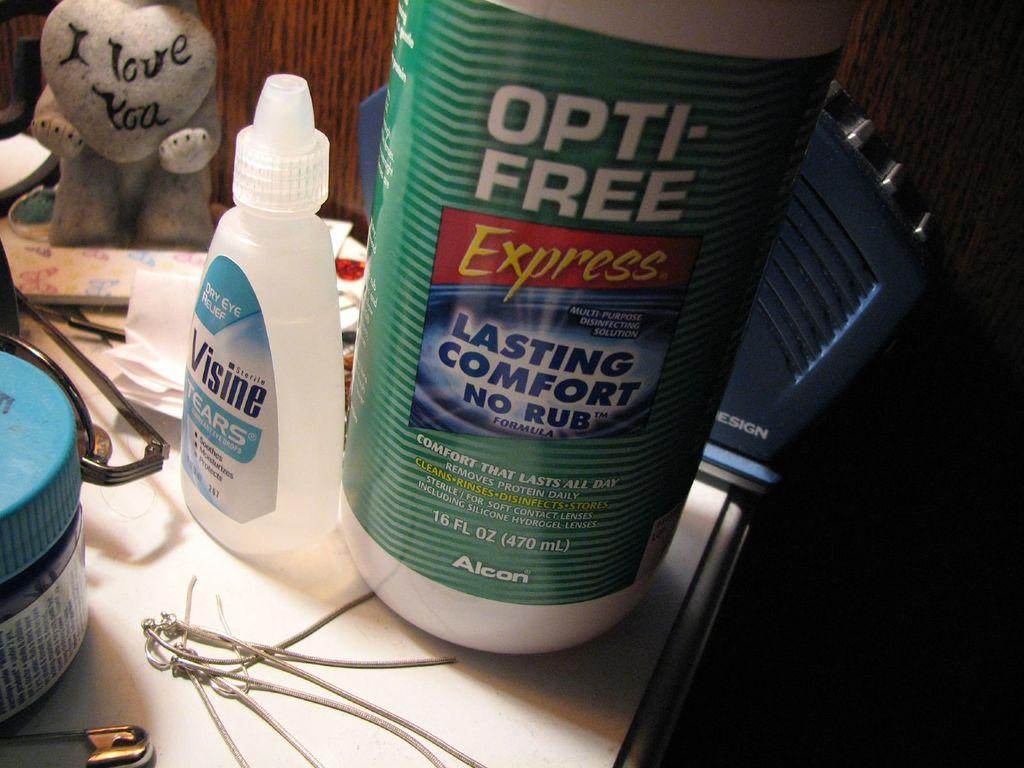What type of furniture is present in the image? There is a table in the image. What can be seen on the table? There is a big bottle, a small bottle, pins, glasses, a small doll, and papers on the table. How many bottles are on the table? There are two bottles on the table, a big one and a small one. What might be used for writing or drawing on the papers? Pens or pencils might be used for writing or drawing on the papers, but they are not visible in the image. Can you see any cows fighting with the father in the image? There are no cows or any fighting depicted in the image; it only shows a table with various objects on it. 